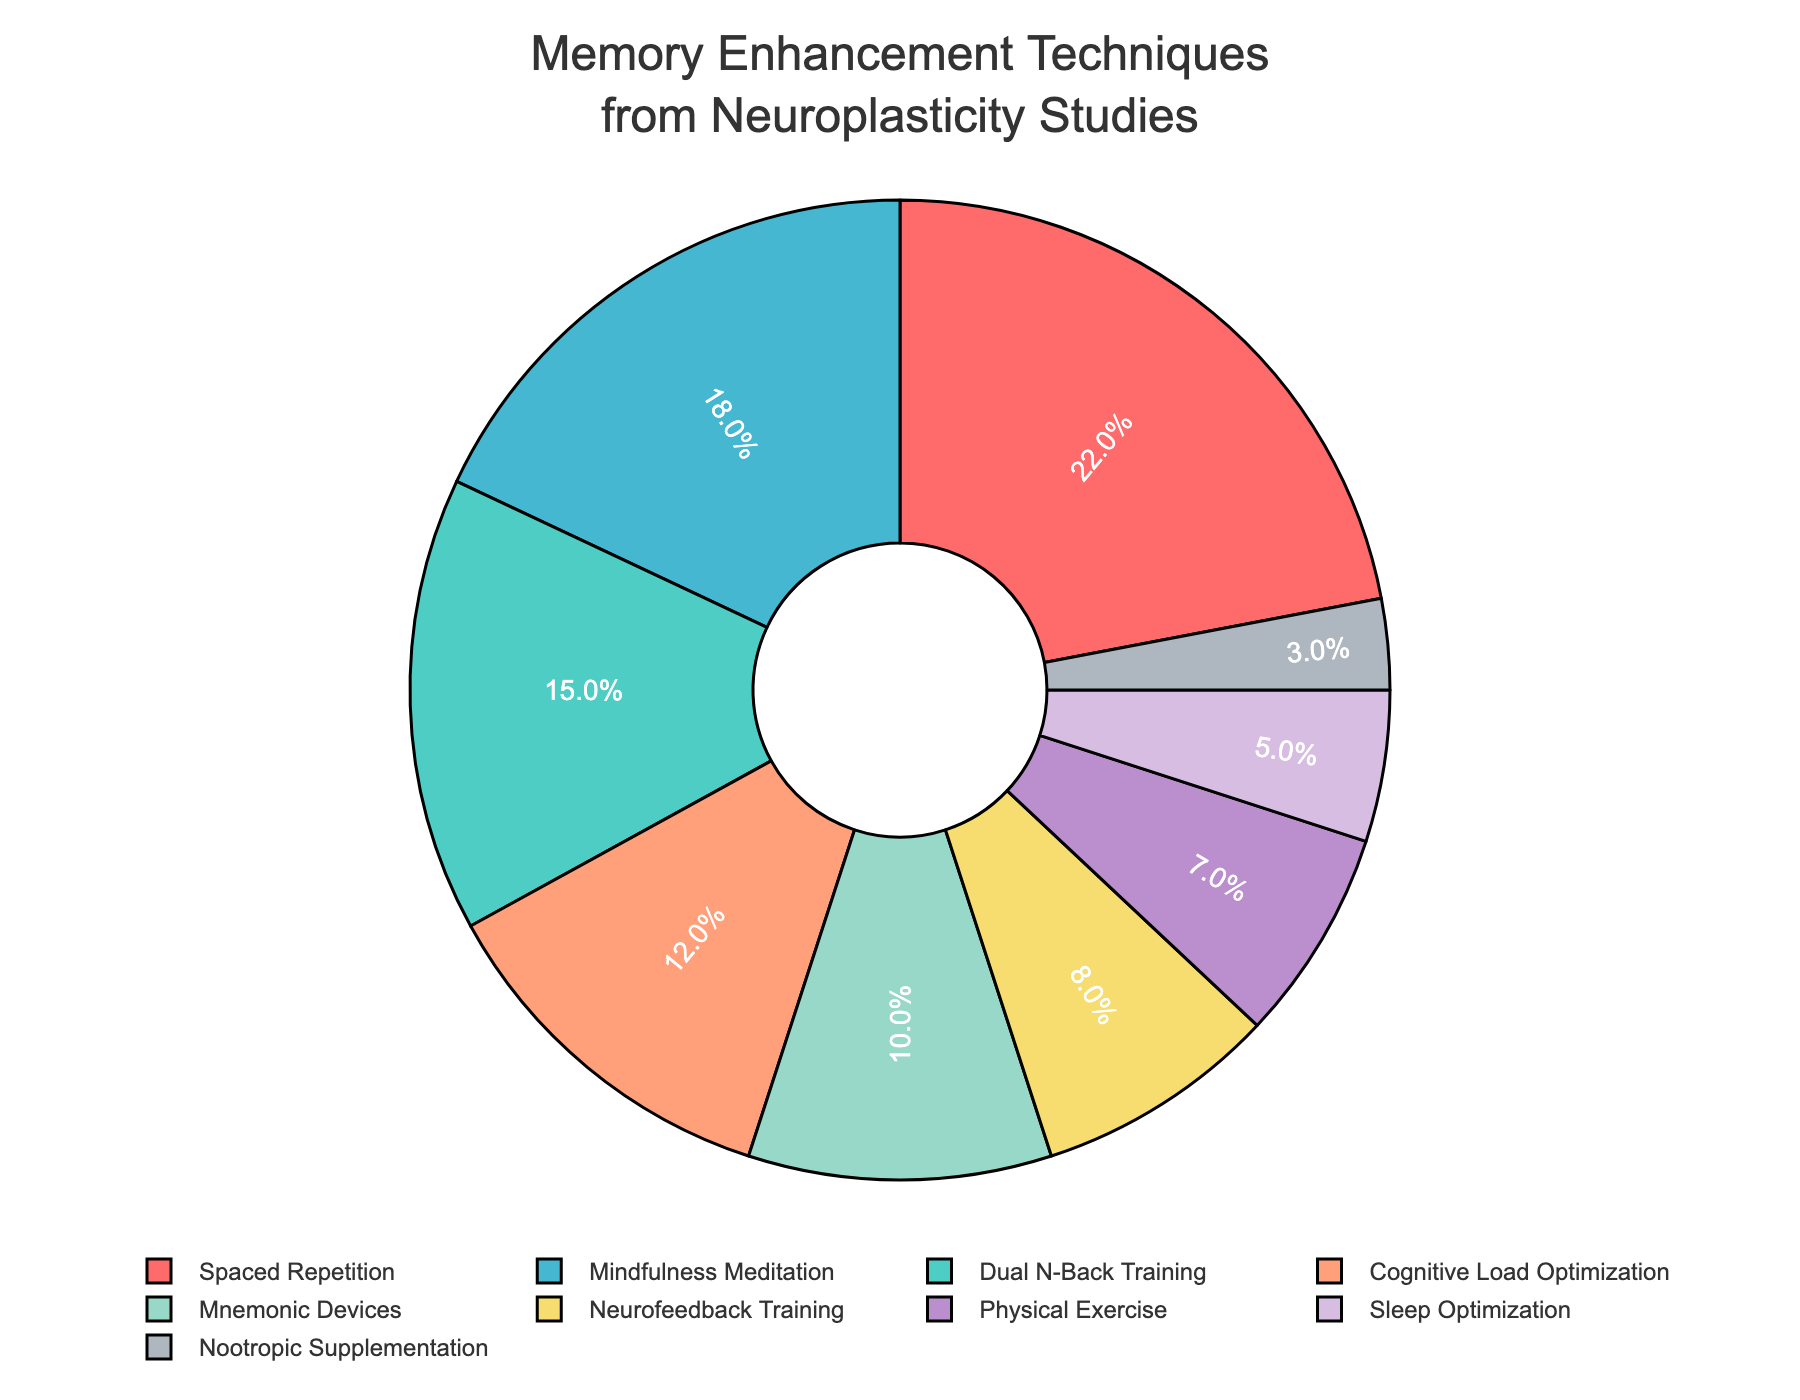What is the technique with the highest percentage? To determine the technique with the highest percentage, look at the pie chart and identify the segment with the largest size. The label and percentage inside this segment will indicate the highest percentage technique.
Answer: Spaced Repetition How much more percentage does Spaced Repetition have compared to Dual N-Back Training? First, identify the percentages of Spaced Repetition and Dual N-Back Training from the pie chart. Spaced Repetition is 22% and Dual N-Back Training is 15%. Subtract the smaller percentage from the larger one: 22% - 15% = 7%.
Answer: 7% What is the combined percentage of Mindfulness Meditation and Cognitive Load Optimization? Locate the percentages for Mindfulness Meditation (18%) and Cognitive Load Optimization (12%) on the pie chart. Add these percentages together: 18% + 12% = 30%.
Answer: 30% Which technique has a smaller percentage, Neurofeedback Training or Physical Exercise? Compare the percentages of Neurofeedback Training (8%) and Physical Exercise (7%) available on the pie chart. Physical Exercise has a smaller percentage.
Answer: Physical Exercise What is the difference in percentage between Mnemonic Devices and Nootropic Supplementation? Identify the percentages for Mnemonic Devices (10%) and Nootropic Supplementation (3%) on the pie chart. Subtract the smaller percentage from the larger one: 10% - 3% = 7%.
Answer: 7% How many techniques have a percentage greater than 10%? Identify all the segments in the pie chart with percentages greater than 10%. They are Spaced Repetition (22%), Dual N-Back Training (15%), Mindfulness Meditation (18%), and Cognitive Load Optimization (12%). There are 4 such techniques.
Answer: 4 What is the total percentage for techniques related to meditation and exercise combined (Mindfulness Meditation and Physical Exercise)? Identify the percentages for Mindfulness Meditation (18%) and Physical Exercise (7%) from the pie chart. Add these percentages together: 18% + 7% = 25%.
Answer: 25% Which technique is represented by the purple color in the pie chart? Look for the segment in the pie chart that is colored purple. According to the provided color scheme, purple corresponds to Neurofeedback Training.
Answer: Neurofeedback Training What percentage of techniques involve a physical component (Physical Exercise and Sleep Optimization)? Locate the percentages for Physical Exercise (7%) and Sleep Optimization (5%) from the pie chart. Add these percentages together: 7% + 5% = 12%.
Answer: 12% Is the percentage of Cognitive Load Optimization equal to the combined percentage of Neurofeedback Training and Sleep Optimization? Identify the percentages for these techniques: Cognitive Load Optimization (12%), Neurofeedback Training (8%), and Sleep Optimization (5%) on the pie chart. Add the percentages of Neurofeedback Training and Sleep Optimization: 8% + 5% = 13%. Compare this with Cognitive Load Optimization: 12% is not equal to 13%.
Answer: No 